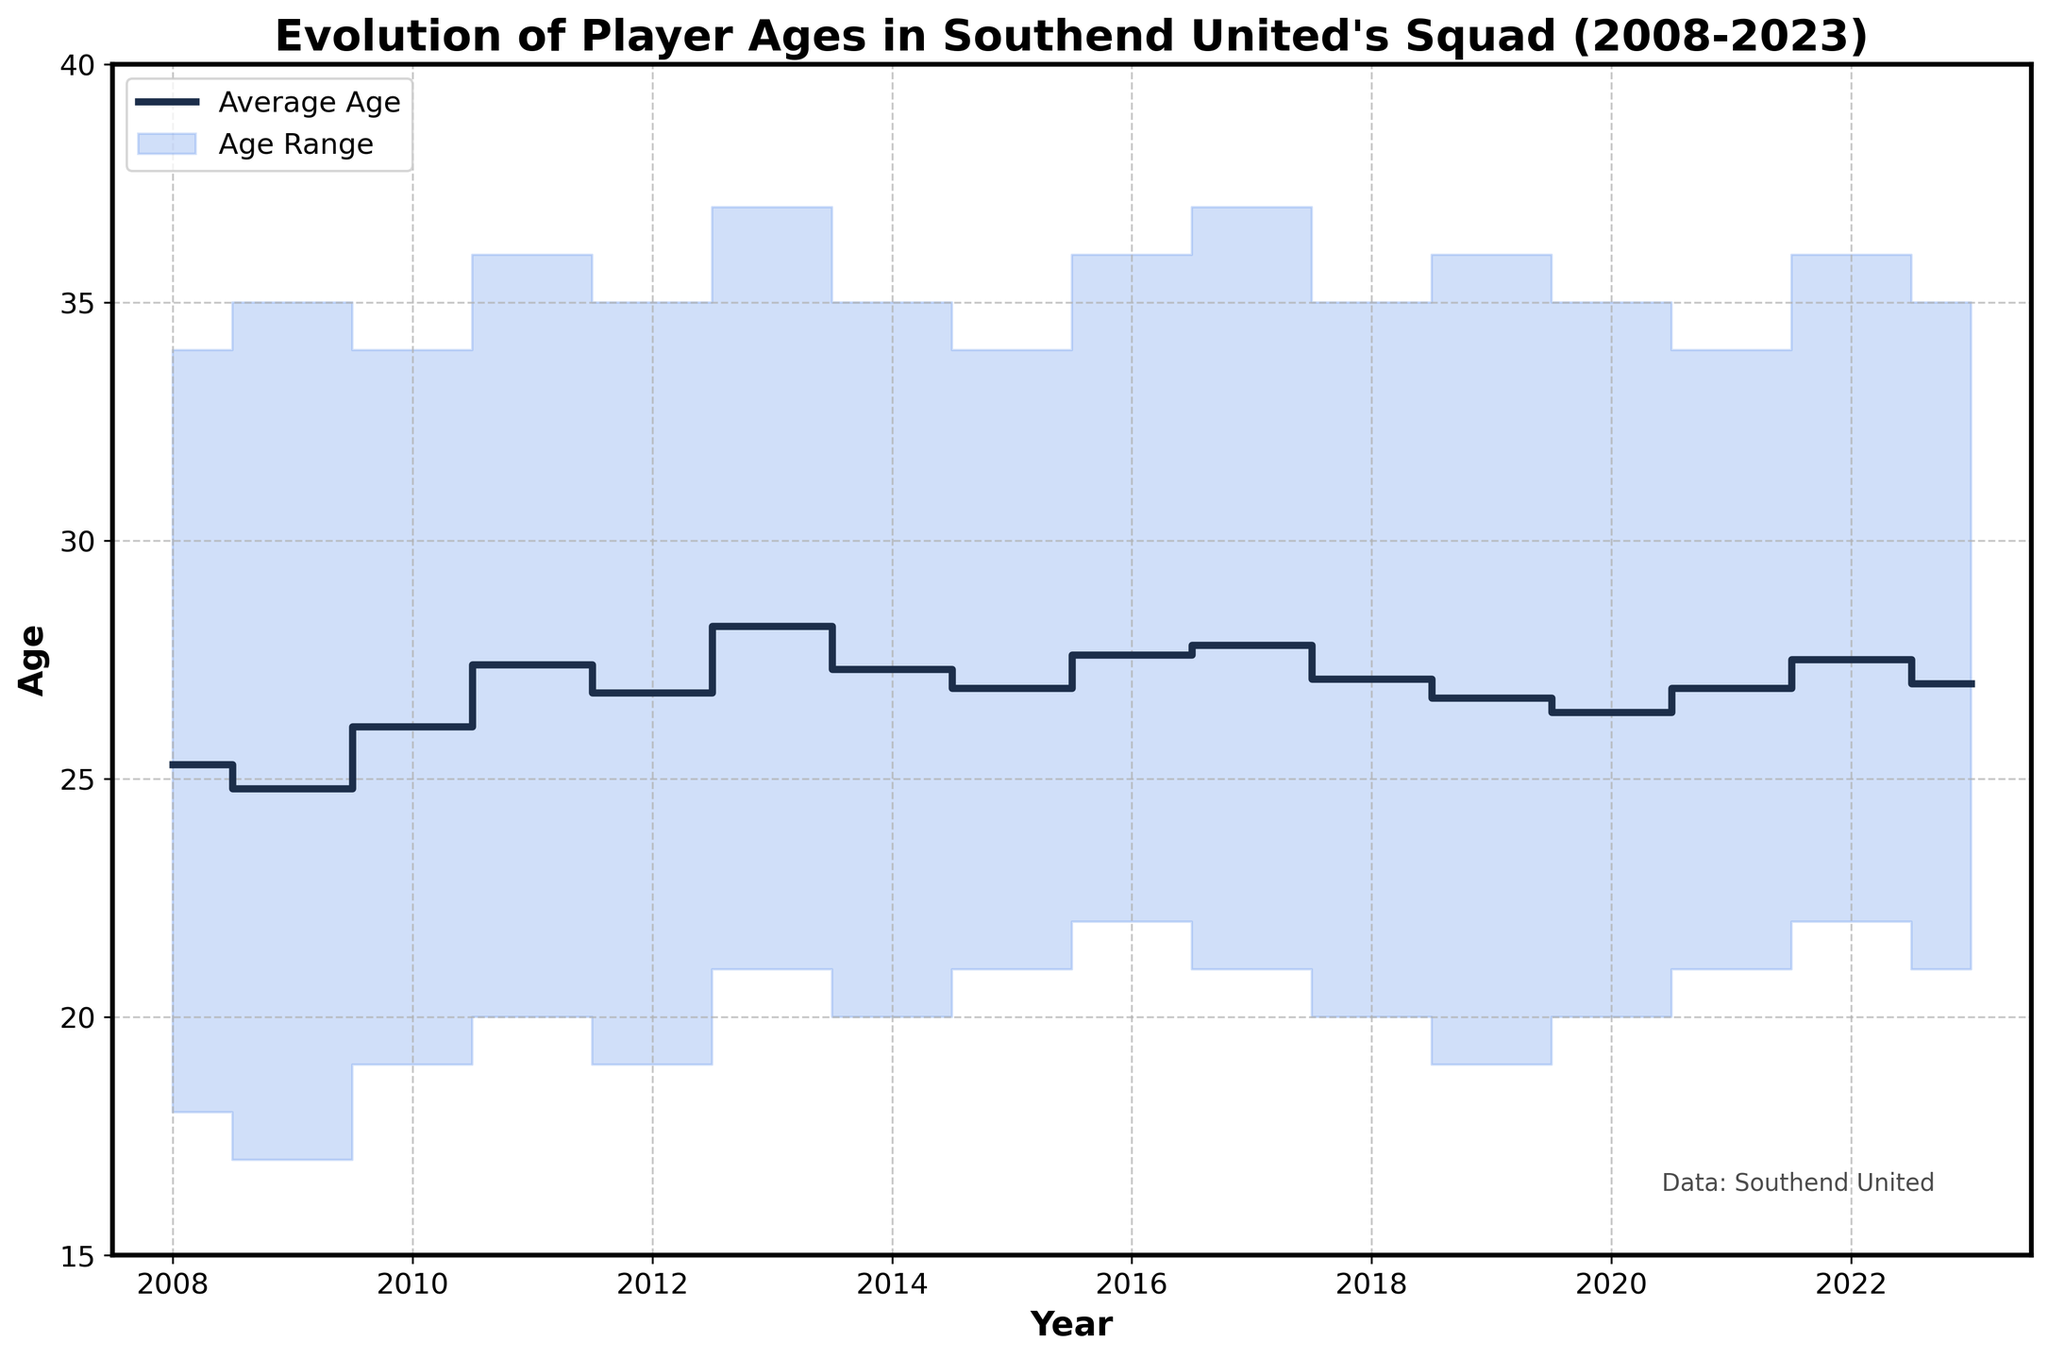What's the title of the figure? The title is located at the top of the figure. It is clearly labeled to provide an overview of what the figure represents.
Answer: Evolution of Player Ages in Southend United's Squad (2008-2023) What year had the oldest maximum age within the squad? The highest point in the "Max_Age" series indicates the oldest maximum age.
Answer: 2013 and 2017 Which year had the youngest minimum age within the squad? The lowest point in the "Min_Age" series indicates the youngest minimum age.
Answer: 2009 What is the overall trend of average age from 2008 to 2023? Visual inspection of the "Average Age" step line shows the change over the years. The overall trend can be observed by noting the direction of successive steps.
Answer: Slight upward trend What is the age range (difference between max and min age) for 2022? The age range can be calculated by subtracting the min age from the max age for the given year.
Answer: 14 In which year did the average age peak, and what was it? The peak of the "Average Age" series indicates the highest value and its corresponding year.
Answer: 2013, 28.2 How did the average age change from 2009 to 2010? Subtract the average age of 2009 from that of 2010 to find the change.
Answer: Increased by 1.3 What was the minimum age in 2020 and the following year's average age? Find the minimum age in the data for 2020 and then check the average age for 2021.
Answer: 20 and 26.9 Did any year have an average age lower than 27 and a maximum age higher than 35? Look through the years where the average age is below 27 and then verify if the maximum age exceeds 35 in those years.
Answer: Yes, 2009 and 2019 What is the difference between the highest and lowest minimum age recorded? Identify the maximum and minimum values from the "Min_Age" series and subtract the lowest from the highest.
Answer: 5 